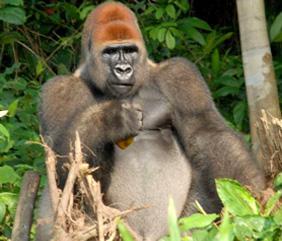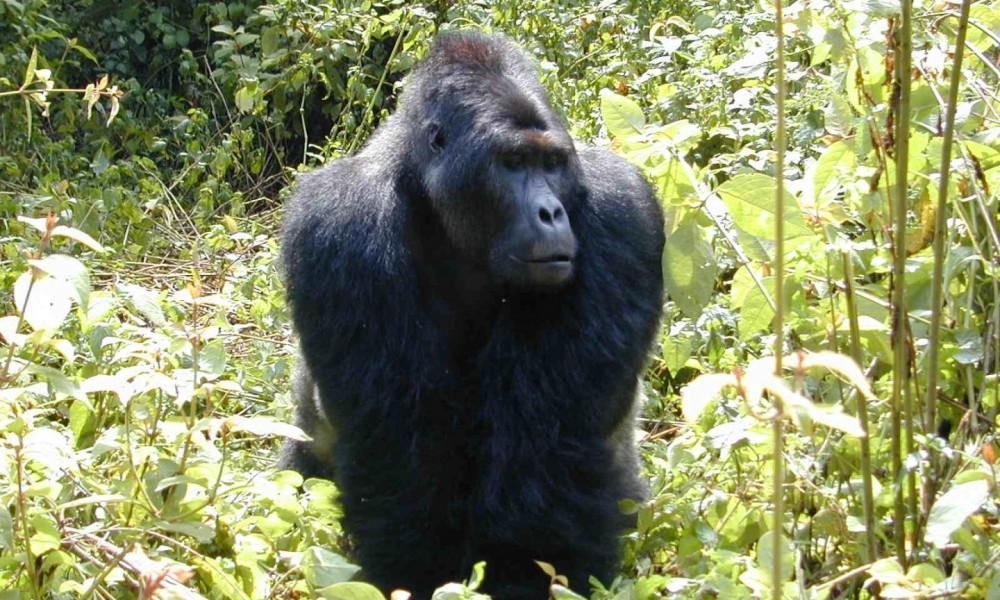The first image is the image on the left, the second image is the image on the right. Assess this claim about the two images: "There are exactly two gorillas in total.". Correct or not? Answer yes or no. Yes. The first image is the image on the left, the second image is the image on the right. Assess this claim about the two images: "There are no more than two apes in total.". Correct or not? Answer yes or no. Yes. 